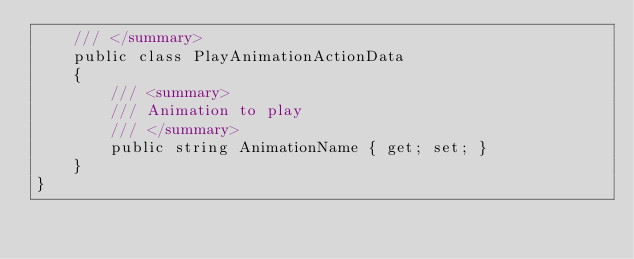<code> <loc_0><loc_0><loc_500><loc_500><_C#_>    /// </summary>
    public class PlayAnimationActionData
    {
        /// <summary>
        /// Animation to play
        /// </summary>
        public string AnimationName { get; set; }
    }
}</code> 